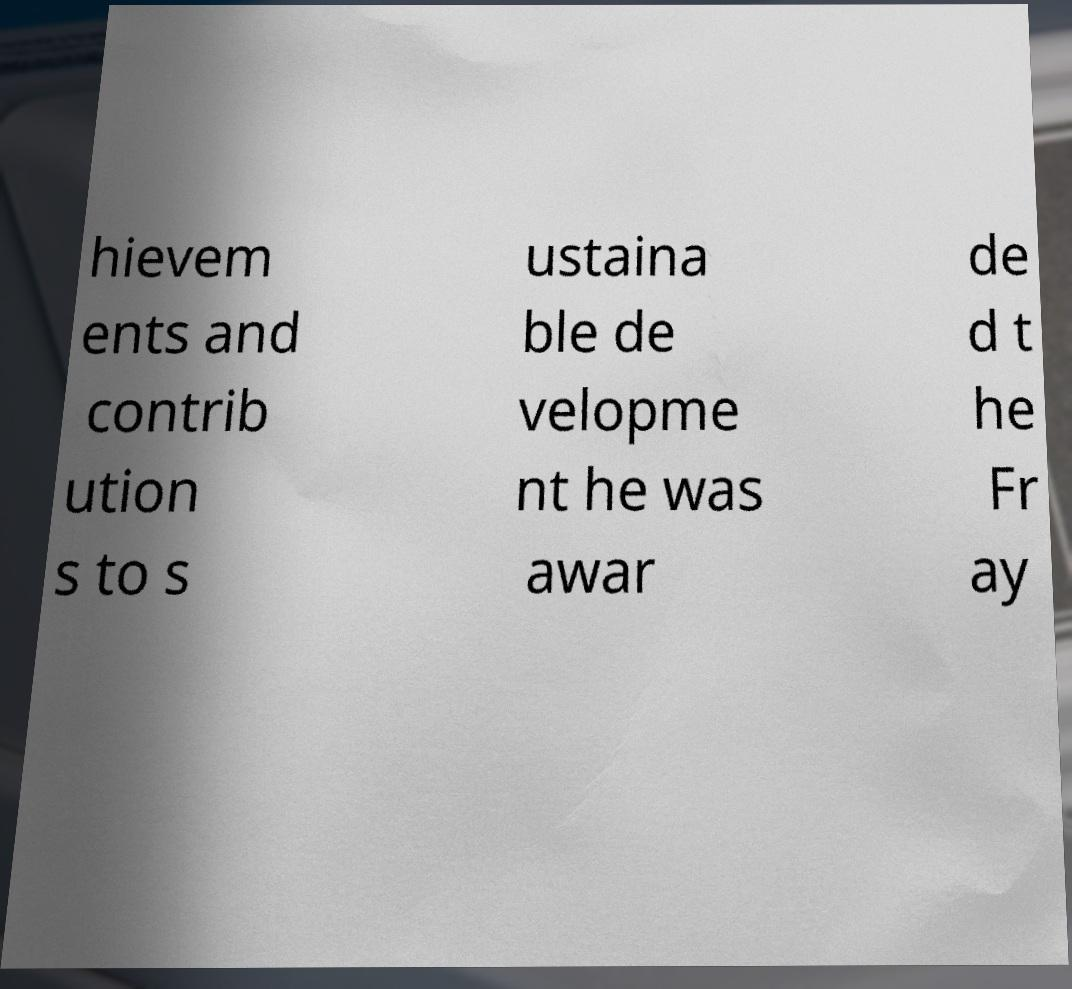There's text embedded in this image that I need extracted. Can you transcribe it verbatim? hievem ents and contrib ution s to s ustaina ble de velopme nt he was awar de d t he Fr ay 